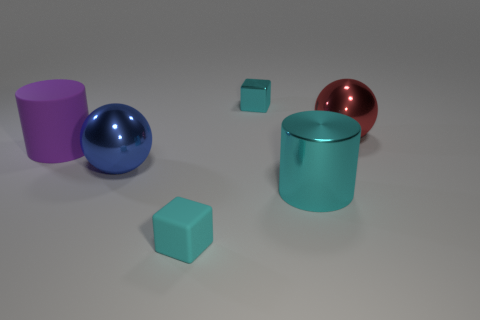Do the matte block and the object behind the red ball have the same color?
Your answer should be very brief. Yes. There is a rubber object behind the large cyan metal cylinder; how many red shiny things are to the left of it?
Ensure brevity in your answer.  0. What size is the thing that is on the left side of the large cyan thing and behind the large purple cylinder?
Your response must be concise. Small. Is there a cyan metallic block that has the same size as the cyan metallic cylinder?
Give a very brief answer. No. Is the number of big cyan cylinders that are behind the purple thing greater than the number of big blue objects on the right side of the cyan metal cylinder?
Give a very brief answer. No. Is the material of the red sphere the same as the cylinder in front of the rubber cylinder?
Your answer should be compact. Yes. There is a purple matte cylinder in front of the tiny cyan block behind the matte cube; how many big objects are behind it?
Offer a terse response. 1. Does the big cyan object have the same shape as the small cyan thing that is in front of the blue shiny ball?
Provide a short and direct response. No. The big metal thing that is in front of the large matte object and to the right of the tiny cyan matte thing is what color?
Ensure brevity in your answer.  Cyan. The tiny thing behind the metallic cylinder that is on the left side of the big ball on the right side of the shiny cylinder is made of what material?
Offer a terse response. Metal. 